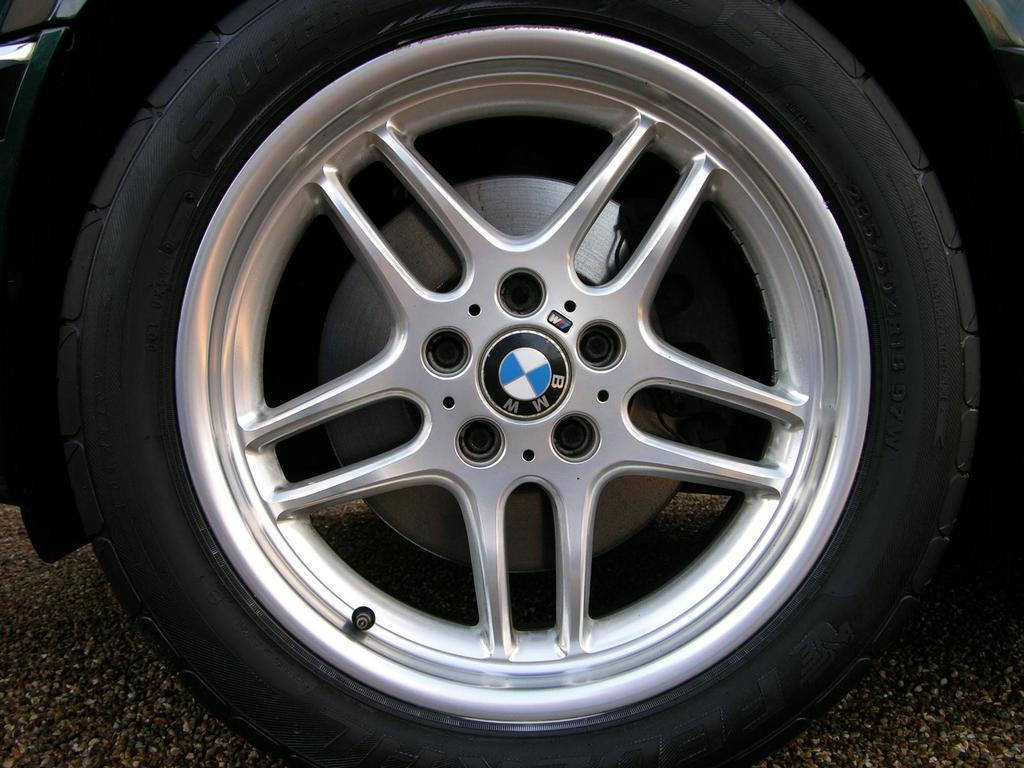What is the main subject of the image? The main subject of the image is a car wheel. What type of roof can be seen on the car in the image? There is no car or roof present in the image; it only features a car wheel. 